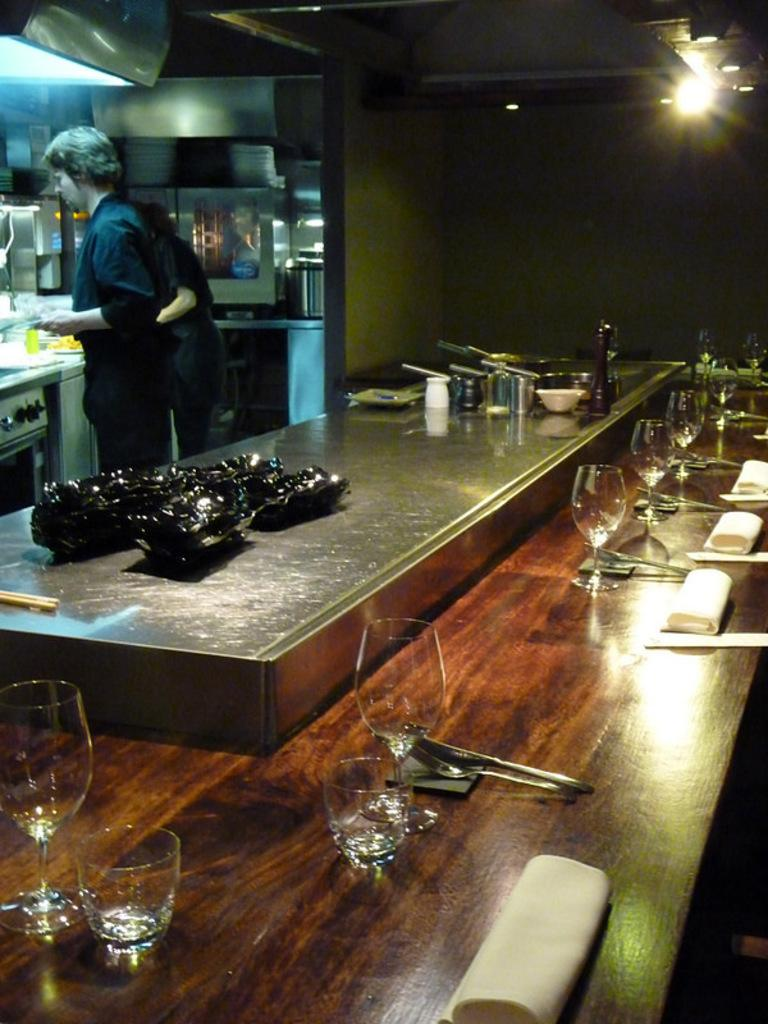What type of room is shown in the image? The image depicts a kitchen. How many people are in the kitchen? There are two men standing in the kitchen. What items can be seen on the table in the image? There are glasses, forks, and spoons on the table. What type of bird is sitting on the fifth man's shoulder in the image? There is no fifth man or bird present in the image; there are only two men in the kitchen. 